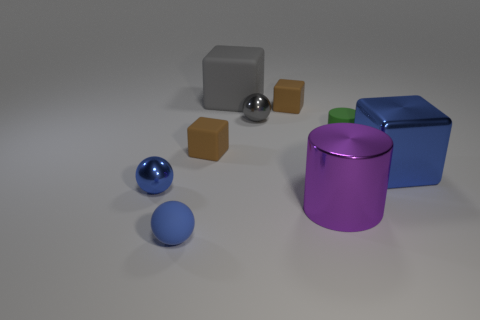Subtract all yellow cubes. Subtract all cyan cylinders. How many cubes are left? 4 Subtract all cylinders. How many objects are left? 7 Add 7 gray balls. How many gray balls are left? 8 Add 3 metallic balls. How many metallic balls exist? 5 Subtract 2 blue balls. How many objects are left? 7 Subtract all matte spheres. Subtract all big cyan metal cylinders. How many objects are left? 8 